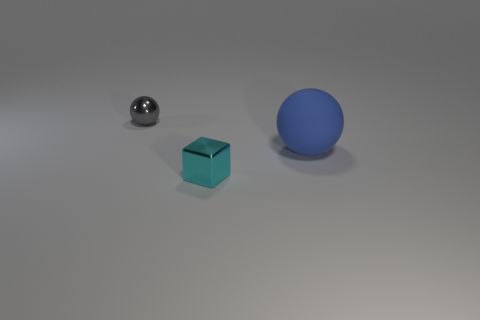Is the shape of the large blue object the same as the object in front of the blue object?
Give a very brief answer. No. What is the size of the object that is both right of the small gray ball and behind the metal block?
Your response must be concise. Large. How many large cubes are there?
Provide a short and direct response. 0. There is a cube that is the same size as the metallic sphere; what is it made of?
Your answer should be compact. Metal. Are there any matte things of the same size as the gray shiny ball?
Your answer should be compact. No. There is a metallic thing that is behind the block; does it have the same color as the ball on the right side of the small cyan block?
Your answer should be compact. No. What number of shiny objects are either blue things or big green blocks?
Your answer should be very brief. 0. How many shiny things are in front of the tiny thing that is behind the cyan thing to the left of the matte thing?
Ensure brevity in your answer.  1. There is a thing that is the same material as the block; what size is it?
Your response must be concise. Small. Is the size of the object to the left of the cyan cube the same as the big sphere?
Your answer should be very brief. No. 